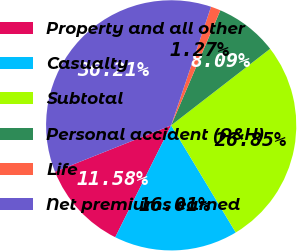Convert chart. <chart><loc_0><loc_0><loc_500><loc_500><pie_chart><fcel>Property and all other<fcel>Casualty<fcel>Subtotal<fcel>Personal accident (A&H)<fcel>Life<fcel>Net premiums earned<nl><fcel>11.58%<fcel>16.01%<fcel>26.85%<fcel>8.09%<fcel>1.27%<fcel>36.21%<nl></chart> 